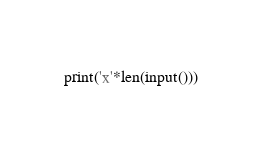Convert code to text. <code><loc_0><loc_0><loc_500><loc_500><_Python_>print('x'*len(input()))</code> 